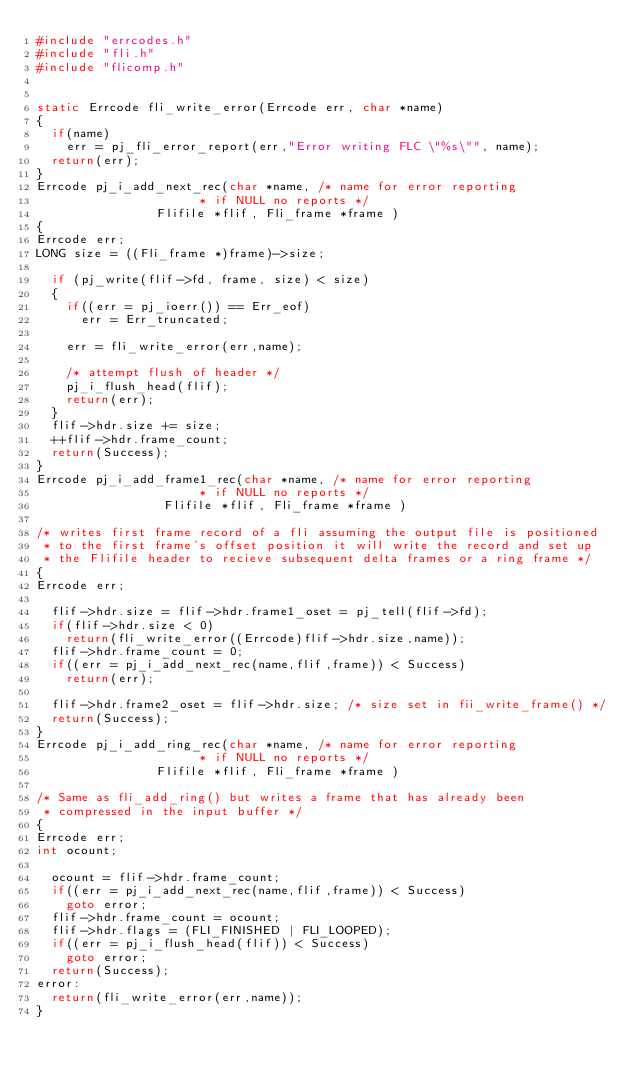<code> <loc_0><loc_0><loc_500><loc_500><_C_>#include "errcodes.h"
#include "fli.h"
#include "flicomp.h"


static Errcode fli_write_error(Errcode err, char *name)
{
	if(name)
		err = pj_fli_error_report(err,"Error writing FLC \"%s\"", name);
	return(err);
}
Errcode pj_i_add_next_rec(char *name, /* name for error reporting
										  * if NULL no reports */
							  Flifile *flif, Fli_frame *frame )
{
Errcode err;
LONG size = ((Fli_frame *)frame)->size;

	if (pj_write(flif->fd, frame, size) < size)
	{
		if((err = pj_ioerr()) == Err_eof)
			err = Err_truncated;

		err = fli_write_error(err,name);

		/* attempt flush of header */
		pj_i_flush_head(flif);
		return(err);
	}
	flif->hdr.size += size;
	++flif->hdr.frame_count;
	return(Success);
}
Errcode pj_i_add_frame1_rec(char *name, /* name for error reporting
										  * if NULL no reports */
							   Flifile *flif, Fli_frame *frame )

/* writes first frame record of a fli assuming the output file is positioned
 * to the first frame's offset position it will write the record and set up
 * the Flifile header to recieve subsequent delta frames or a ring frame */
{
Errcode err;

	flif->hdr.size = flif->hdr.frame1_oset = pj_tell(flif->fd);
	if(flif->hdr.size < 0)
		return(fli_write_error((Errcode)flif->hdr.size,name));
	flif->hdr.frame_count = 0;
	if((err = pj_i_add_next_rec(name,flif,frame)) < Success)
		return(err);

	flif->hdr.frame2_oset = flif->hdr.size; /* size set in fii_write_frame() */
	return(Success);
}
Errcode pj_i_add_ring_rec(char *name, /* name for error reporting
										  * if NULL no reports */
							  Flifile *flif, Fli_frame *frame )

/* Same as fli_add_ring() but writes a frame that has already been
 * compressed in the input buffer */
{
Errcode err;
int ocount;

	ocount = flif->hdr.frame_count;
	if((err = pj_i_add_next_rec(name,flif,frame)) < Success)
		goto error;
	flif->hdr.frame_count = ocount;
	flif->hdr.flags = (FLI_FINISHED | FLI_LOOPED);
	if((err = pj_i_flush_head(flif)) < Success)
		goto error;
	return(Success);
error:
	return(fli_write_error(err,name));
}
</code> 